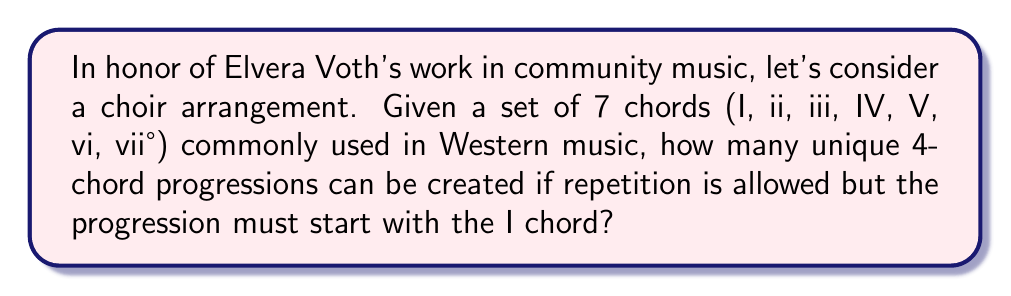Can you answer this question? Let's approach this step-by-step:

1) We start with the I chord, so we only need to determine the remaining 3 chords.

2) For each of these 3 positions, we have 7 choices (as repetition is allowed).

3) This is a case of the multiplication principle in combinatorics. When we have $n$ independent choices, each with $m_i$ options, the total number of possibilities is:

   $$\prod_{i=1}^n m_i$$

4) In our case, we have 3 positions (n = 3), and each position has 7 choices (m_i = 7 for all i).

5) Therefore, the total number of unique progressions is:

   $$7 \times 7 \times 7 = 7^3 = 343$$

This calculation represents the number of ways to fill 3 positions, each with 7 choices, after the fixed I chord at the beginning.
Answer: 343 